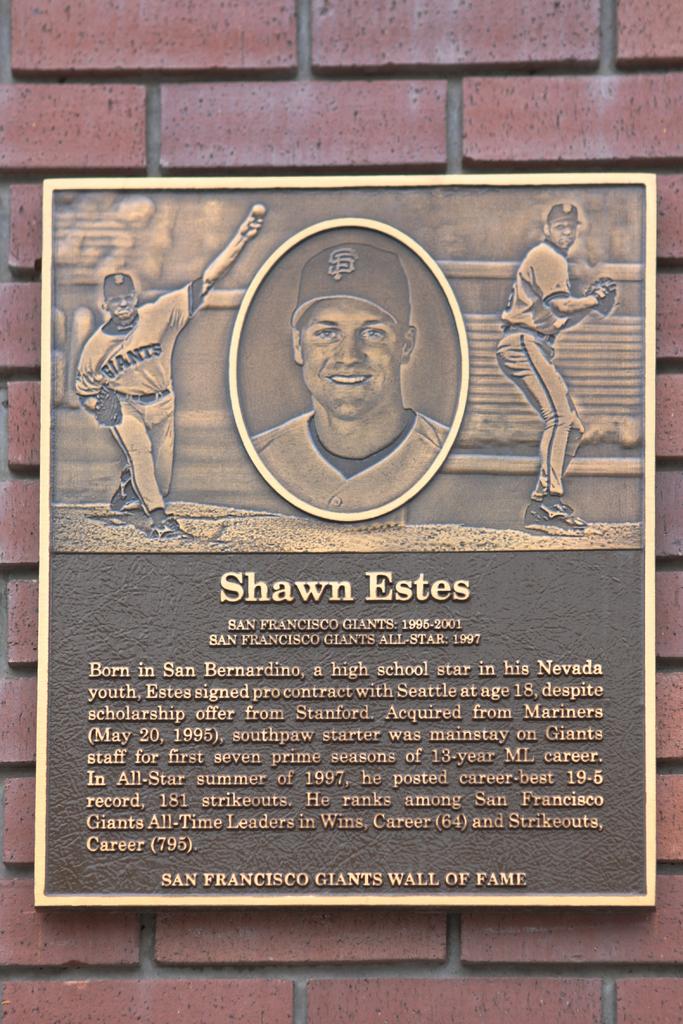What city are the giants from?
Offer a terse response. San francisco. Who is this plaque for?
Offer a terse response. Shawn estes. 